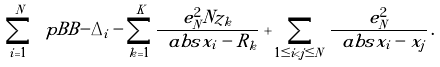<formula> <loc_0><loc_0><loc_500><loc_500>\sum _ { i = 1 } ^ { N } \ p B B { - \Delta _ { i } - \sum _ { k = 1 } ^ { K } \frac { e _ { N } ^ { 2 } N z _ { k } } { \ a b s { x _ { i } - R _ { k } } } } + \sum _ { 1 \leq i < j \leq N } \frac { e _ { N } ^ { 2 } } { \ a b s { x _ { i } - x _ { j } } } \, .</formula> 